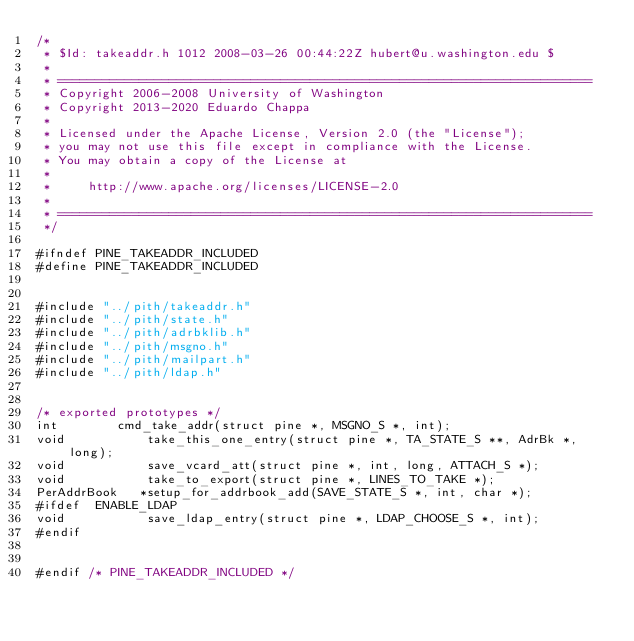Convert code to text. <code><loc_0><loc_0><loc_500><loc_500><_C_>/*
 * $Id: takeaddr.h 1012 2008-03-26 00:44:22Z hubert@u.washington.edu $
 *
 * ========================================================================
 * Copyright 2006-2008 University of Washington
 * Copyright 2013-2020 Eduardo Chappa
 *
 * Licensed under the Apache License, Version 2.0 (the "License");
 * you may not use this file except in compliance with the License.
 * You may obtain a copy of the License at
 *
 *     http://www.apache.org/licenses/LICENSE-2.0
 *
 * ========================================================================
 */

#ifndef PINE_TAKEADDR_INCLUDED
#define PINE_TAKEADDR_INCLUDED


#include "../pith/takeaddr.h"
#include "../pith/state.h"
#include "../pith/adrbklib.h"
#include "../pith/msgno.h"
#include "../pith/mailpart.h"
#include "../pith/ldap.h"


/* exported prototypes */
int	       cmd_take_addr(struct pine *, MSGNO_S *, int);
void           take_this_one_entry(struct pine *, TA_STATE_S **, AdrBk *, long);
void           save_vcard_att(struct pine *, int, long, ATTACH_S *);
void           take_to_export(struct pine *, LINES_TO_TAKE *);
PerAddrBook   *setup_for_addrbook_add(SAVE_STATE_S *, int, char *);
#ifdef	ENABLE_LDAP
void           save_ldap_entry(struct pine *, LDAP_CHOOSE_S *, int);
#endif


#endif /* PINE_TAKEADDR_INCLUDED */
</code> 